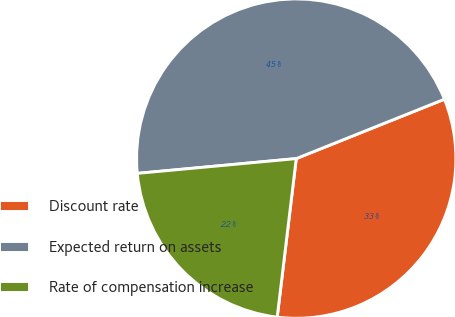<chart> <loc_0><loc_0><loc_500><loc_500><pie_chart><fcel>Discount rate<fcel>Expected return on assets<fcel>Rate of compensation increase<nl><fcel>32.97%<fcel>45.41%<fcel>21.62%<nl></chart> 